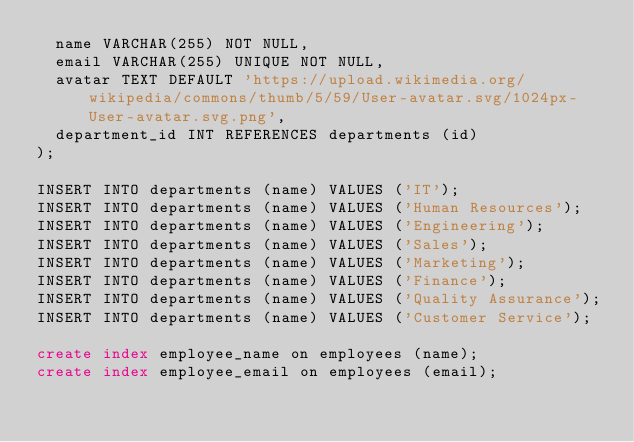Convert code to text. <code><loc_0><loc_0><loc_500><loc_500><_SQL_>  name VARCHAR(255) NOT NULL,
  email VARCHAR(255) UNIQUE NOT NULL,
  avatar TEXT DEFAULT 'https://upload.wikimedia.org/wikipedia/commons/thumb/5/59/User-avatar.svg/1024px-User-avatar.svg.png',
  department_id INT REFERENCES departments (id)
);

INSERT INTO departments (name) VALUES ('IT');
INSERT INTO departments (name) VALUES ('Human Resources');
INSERT INTO departments (name) VALUES ('Engineering');
INSERT INTO departments (name) VALUES ('Sales');
INSERT INTO departments (name) VALUES ('Marketing');
INSERT INTO departments (name) VALUES ('Finance');
INSERT INTO departments (name) VALUES ('Quality Assurance');
INSERT INTO departments (name) VALUES ('Customer Service');

create index employee_name on employees (name);
create index employee_email on employees (email);</code> 